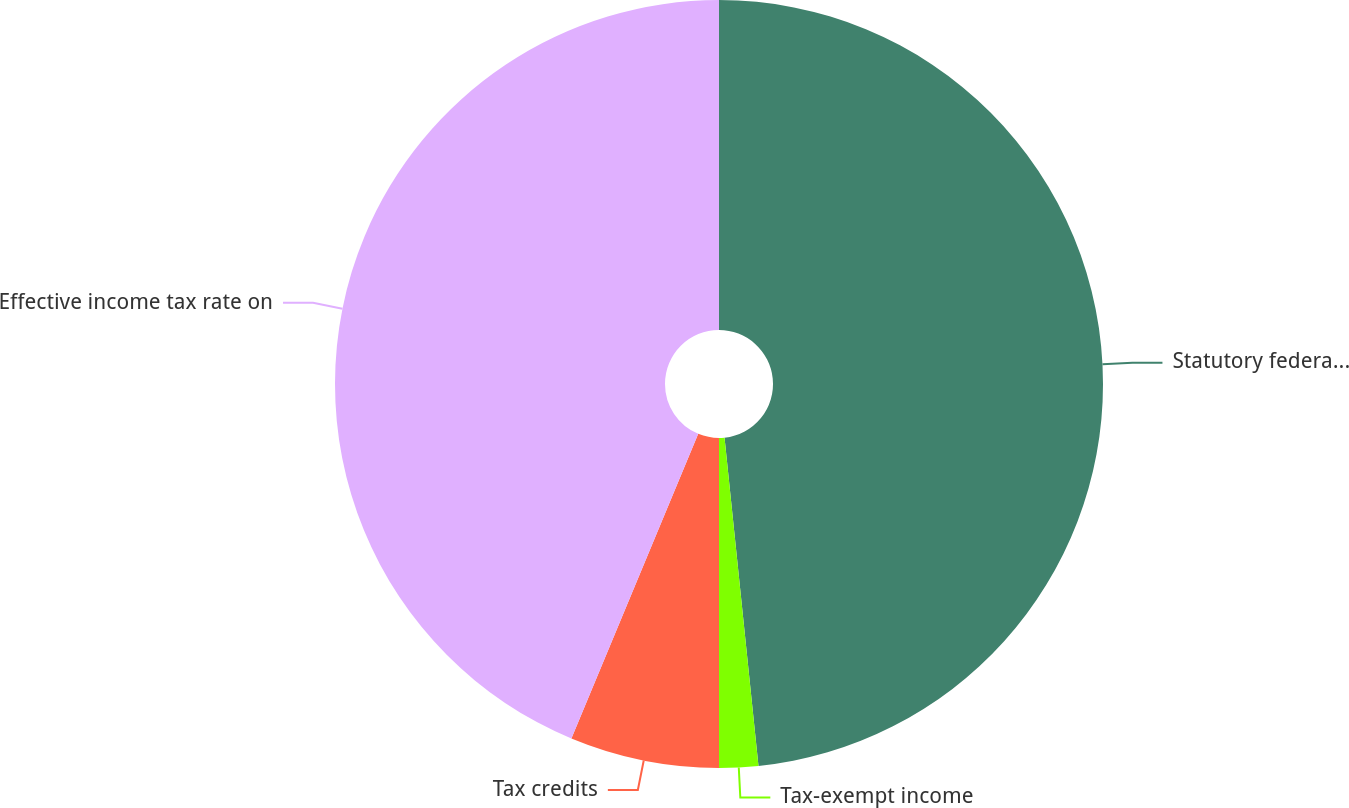Convert chart to OTSL. <chart><loc_0><loc_0><loc_500><loc_500><pie_chart><fcel>Statutory federal income tax<fcel>Tax-exempt income<fcel>Tax credits<fcel>Effective income tax rate on<nl><fcel>48.36%<fcel>1.64%<fcel>6.28%<fcel>43.72%<nl></chart> 